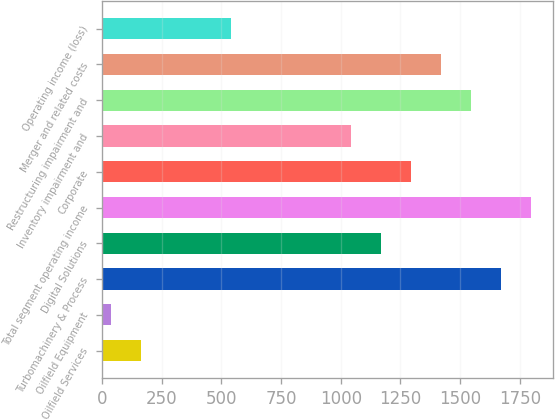<chart> <loc_0><loc_0><loc_500><loc_500><bar_chart><fcel>Oilfield Services<fcel>Oilfield Equipment<fcel>Turbomachinery & Process<fcel>Digital Solutions<fcel>Total segment operating income<fcel>Corporate<fcel>Inventory impairment and<fcel>Restructuring impairment and<fcel>Merger and related costs<fcel>Operating income (loss)<nl><fcel>163.7<fcel>38<fcel>1672.1<fcel>1169.3<fcel>1797.8<fcel>1295<fcel>1043.6<fcel>1546.4<fcel>1420.7<fcel>540.8<nl></chart> 